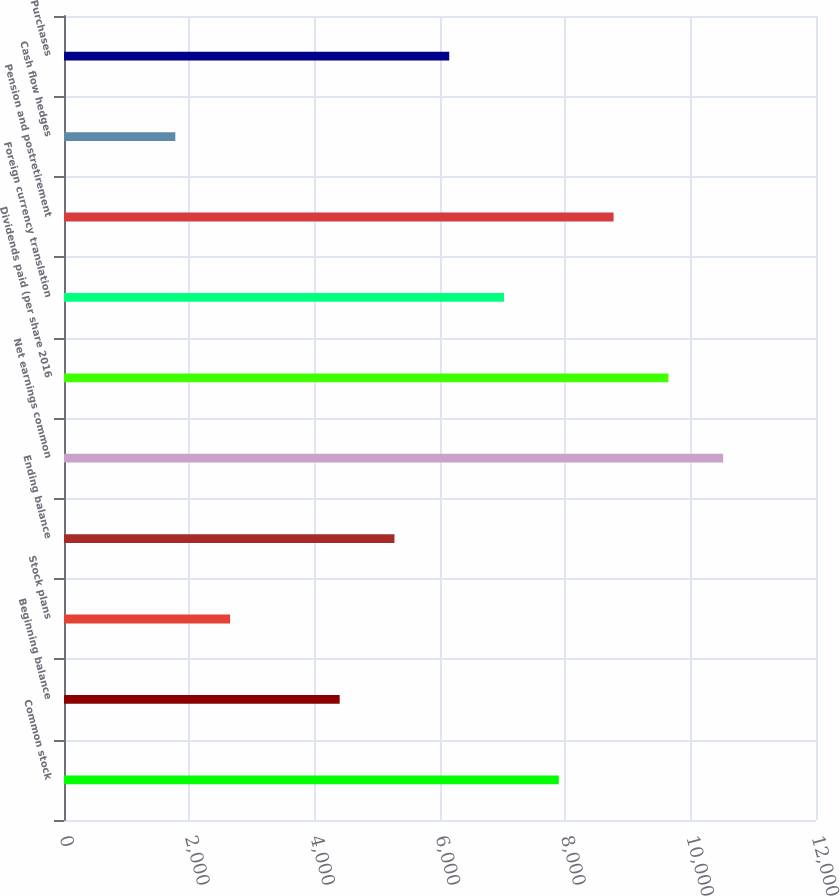<chart> <loc_0><loc_0><loc_500><loc_500><bar_chart><fcel>Common stock<fcel>Beginning balance<fcel>Stock plans<fcel>Ending balance<fcel>Net earnings common<fcel>Dividends paid (per share 2016<fcel>Foreign currency translation<fcel>Pension and postretirement<fcel>Cash flow hedges<fcel>Purchases<nl><fcel>7895.8<fcel>4399<fcel>2650.6<fcel>5273.2<fcel>10518.4<fcel>9644.2<fcel>7021.6<fcel>8770<fcel>1776.4<fcel>6147.4<nl></chart> 